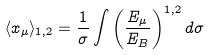Convert formula to latex. <formula><loc_0><loc_0><loc_500><loc_500>\langle x _ { \mu } \rangle _ { 1 , 2 } = \frac { 1 } { \sigma } \int \left ( \frac { E _ { \mu } } { E _ { B } } \right ) ^ { 1 , 2 } d \sigma</formula> 